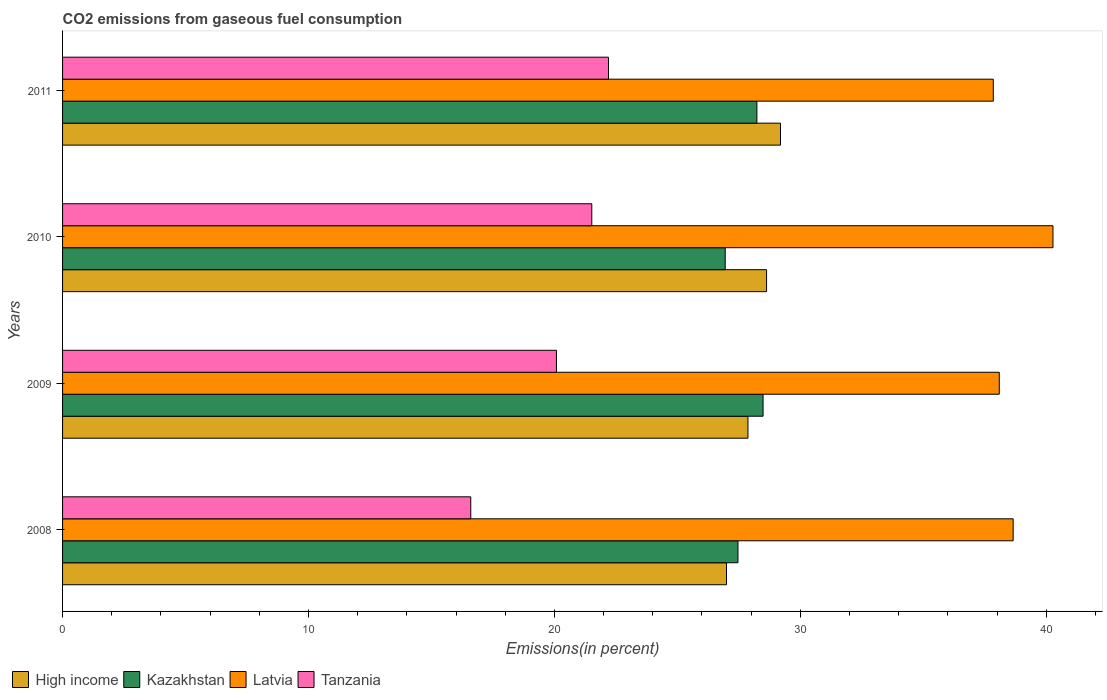Are the number of bars per tick equal to the number of legend labels?
Ensure brevity in your answer.  Yes. Are the number of bars on each tick of the Y-axis equal?
Give a very brief answer. Yes. How many bars are there on the 1st tick from the bottom?
Offer a terse response. 4. What is the label of the 2nd group of bars from the top?
Give a very brief answer. 2010. In how many cases, is the number of bars for a given year not equal to the number of legend labels?
Your answer should be very brief. 0. What is the total CO2 emitted in Kazakhstan in 2010?
Make the answer very short. 26.95. Across all years, what is the maximum total CO2 emitted in High income?
Ensure brevity in your answer.  29.19. Across all years, what is the minimum total CO2 emitted in Tanzania?
Ensure brevity in your answer.  16.6. In which year was the total CO2 emitted in Tanzania maximum?
Offer a terse response. 2011. What is the total total CO2 emitted in High income in the graph?
Ensure brevity in your answer.  112.69. What is the difference between the total CO2 emitted in Kazakhstan in 2008 and that in 2009?
Your answer should be compact. -1.02. What is the difference between the total CO2 emitted in Latvia in 2010 and the total CO2 emitted in Kazakhstan in 2011?
Ensure brevity in your answer.  12.04. What is the average total CO2 emitted in Kazakhstan per year?
Your answer should be very brief. 27.78. In the year 2010, what is the difference between the total CO2 emitted in High income and total CO2 emitted in Kazakhstan?
Provide a short and direct response. 1.68. What is the ratio of the total CO2 emitted in Kazakhstan in 2008 to that in 2009?
Your answer should be very brief. 0.96. Is the total CO2 emitted in High income in 2008 less than that in 2009?
Ensure brevity in your answer.  Yes. Is the difference between the total CO2 emitted in High income in 2010 and 2011 greater than the difference between the total CO2 emitted in Kazakhstan in 2010 and 2011?
Provide a short and direct response. Yes. What is the difference between the highest and the second highest total CO2 emitted in Latvia?
Provide a short and direct response. 1.62. What is the difference between the highest and the lowest total CO2 emitted in Latvia?
Offer a terse response. 2.43. In how many years, is the total CO2 emitted in Tanzania greater than the average total CO2 emitted in Tanzania taken over all years?
Provide a succinct answer. 2. Is it the case that in every year, the sum of the total CO2 emitted in Latvia and total CO2 emitted in High income is greater than the sum of total CO2 emitted in Kazakhstan and total CO2 emitted in Tanzania?
Offer a terse response. Yes. What does the 2nd bar from the bottom in 2011 represents?
Make the answer very short. Kazakhstan. Is it the case that in every year, the sum of the total CO2 emitted in Tanzania and total CO2 emitted in Kazakhstan is greater than the total CO2 emitted in High income?
Your answer should be very brief. Yes. How many years are there in the graph?
Make the answer very short. 4. What is the difference between two consecutive major ticks on the X-axis?
Give a very brief answer. 10. Does the graph contain any zero values?
Provide a succinct answer. No. Does the graph contain grids?
Ensure brevity in your answer.  No. Where does the legend appear in the graph?
Offer a terse response. Bottom left. How many legend labels are there?
Give a very brief answer. 4. What is the title of the graph?
Offer a very short reply. CO2 emissions from gaseous fuel consumption. Does "Botswana" appear as one of the legend labels in the graph?
Provide a succinct answer. No. What is the label or title of the X-axis?
Make the answer very short. Emissions(in percent). What is the label or title of the Y-axis?
Your answer should be compact. Years. What is the Emissions(in percent) in High income in 2008?
Ensure brevity in your answer.  27. What is the Emissions(in percent) of Kazakhstan in 2008?
Provide a short and direct response. 27.46. What is the Emissions(in percent) in Latvia in 2008?
Your response must be concise. 38.65. What is the Emissions(in percent) in Tanzania in 2008?
Offer a very short reply. 16.6. What is the Emissions(in percent) in High income in 2009?
Your response must be concise. 27.87. What is the Emissions(in percent) in Kazakhstan in 2009?
Your answer should be very brief. 28.48. What is the Emissions(in percent) of Latvia in 2009?
Your response must be concise. 38.09. What is the Emissions(in percent) of Tanzania in 2009?
Your response must be concise. 20.08. What is the Emissions(in percent) of High income in 2010?
Give a very brief answer. 28.63. What is the Emissions(in percent) of Kazakhstan in 2010?
Offer a terse response. 26.95. What is the Emissions(in percent) in Latvia in 2010?
Offer a very short reply. 40.27. What is the Emissions(in percent) of Tanzania in 2010?
Provide a succinct answer. 21.52. What is the Emissions(in percent) of High income in 2011?
Provide a succinct answer. 29.19. What is the Emissions(in percent) of Kazakhstan in 2011?
Provide a short and direct response. 28.23. What is the Emissions(in percent) of Latvia in 2011?
Give a very brief answer. 37.85. What is the Emissions(in percent) of Tanzania in 2011?
Keep it short and to the point. 22.2. Across all years, what is the maximum Emissions(in percent) of High income?
Provide a short and direct response. 29.19. Across all years, what is the maximum Emissions(in percent) in Kazakhstan?
Keep it short and to the point. 28.48. Across all years, what is the maximum Emissions(in percent) of Latvia?
Your answer should be compact. 40.27. Across all years, what is the maximum Emissions(in percent) of Tanzania?
Provide a succinct answer. 22.2. Across all years, what is the minimum Emissions(in percent) in High income?
Provide a short and direct response. 27. Across all years, what is the minimum Emissions(in percent) of Kazakhstan?
Your answer should be very brief. 26.95. Across all years, what is the minimum Emissions(in percent) in Latvia?
Give a very brief answer. 37.85. Across all years, what is the minimum Emissions(in percent) in Tanzania?
Offer a very short reply. 16.6. What is the total Emissions(in percent) of High income in the graph?
Give a very brief answer. 112.69. What is the total Emissions(in percent) in Kazakhstan in the graph?
Ensure brevity in your answer.  111.13. What is the total Emissions(in percent) of Latvia in the graph?
Provide a short and direct response. 154.87. What is the total Emissions(in percent) in Tanzania in the graph?
Your answer should be very brief. 80.4. What is the difference between the Emissions(in percent) of High income in 2008 and that in 2009?
Provide a short and direct response. -0.87. What is the difference between the Emissions(in percent) in Kazakhstan in 2008 and that in 2009?
Provide a short and direct response. -1.02. What is the difference between the Emissions(in percent) of Latvia in 2008 and that in 2009?
Offer a very short reply. 0.56. What is the difference between the Emissions(in percent) in Tanzania in 2008 and that in 2009?
Provide a short and direct response. -3.48. What is the difference between the Emissions(in percent) of High income in 2008 and that in 2010?
Offer a terse response. -1.63. What is the difference between the Emissions(in percent) in Kazakhstan in 2008 and that in 2010?
Keep it short and to the point. 0.52. What is the difference between the Emissions(in percent) in Latvia in 2008 and that in 2010?
Your answer should be compact. -1.62. What is the difference between the Emissions(in percent) in Tanzania in 2008 and that in 2010?
Provide a short and direct response. -4.92. What is the difference between the Emissions(in percent) of High income in 2008 and that in 2011?
Your response must be concise. -2.19. What is the difference between the Emissions(in percent) of Kazakhstan in 2008 and that in 2011?
Offer a very short reply. -0.77. What is the difference between the Emissions(in percent) in Latvia in 2008 and that in 2011?
Provide a succinct answer. 0.81. What is the difference between the Emissions(in percent) of Tanzania in 2008 and that in 2011?
Your response must be concise. -5.6. What is the difference between the Emissions(in percent) in High income in 2009 and that in 2010?
Offer a terse response. -0.76. What is the difference between the Emissions(in percent) of Kazakhstan in 2009 and that in 2010?
Give a very brief answer. 1.54. What is the difference between the Emissions(in percent) in Latvia in 2009 and that in 2010?
Offer a terse response. -2.18. What is the difference between the Emissions(in percent) of Tanzania in 2009 and that in 2010?
Offer a terse response. -1.44. What is the difference between the Emissions(in percent) of High income in 2009 and that in 2011?
Offer a terse response. -1.32. What is the difference between the Emissions(in percent) in Kazakhstan in 2009 and that in 2011?
Your response must be concise. 0.25. What is the difference between the Emissions(in percent) of Latvia in 2009 and that in 2011?
Offer a terse response. 0.24. What is the difference between the Emissions(in percent) of Tanzania in 2009 and that in 2011?
Provide a succinct answer. -2.12. What is the difference between the Emissions(in percent) of High income in 2010 and that in 2011?
Provide a succinct answer. -0.57. What is the difference between the Emissions(in percent) of Kazakhstan in 2010 and that in 2011?
Provide a short and direct response. -1.29. What is the difference between the Emissions(in percent) of Latvia in 2010 and that in 2011?
Give a very brief answer. 2.43. What is the difference between the Emissions(in percent) of Tanzania in 2010 and that in 2011?
Your answer should be compact. -0.68. What is the difference between the Emissions(in percent) of High income in 2008 and the Emissions(in percent) of Kazakhstan in 2009?
Your answer should be compact. -1.49. What is the difference between the Emissions(in percent) of High income in 2008 and the Emissions(in percent) of Latvia in 2009?
Ensure brevity in your answer.  -11.09. What is the difference between the Emissions(in percent) in High income in 2008 and the Emissions(in percent) in Tanzania in 2009?
Give a very brief answer. 6.92. What is the difference between the Emissions(in percent) of Kazakhstan in 2008 and the Emissions(in percent) of Latvia in 2009?
Your answer should be compact. -10.63. What is the difference between the Emissions(in percent) of Kazakhstan in 2008 and the Emissions(in percent) of Tanzania in 2009?
Keep it short and to the point. 7.38. What is the difference between the Emissions(in percent) in Latvia in 2008 and the Emissions(in percent) in Tanzania in 2009?
Offer a very short reply. 18.57. What is the difference between the Emissions(in percent) of High income in 2008 and the Emissions(in percent) of Kazakhstan in 2010?
Your answer should be compact. 0.05. What is the difference between the Emissions(in percent) of High income in 2008 and the Emissions(in percent) of Latvia in 2010?
Ensure brevity in your answer.  -13.28. What is the difference between the Emissions(in percent) of High income in 2008 and the Emissions(in percent) of Tanzania in 2010?
Ensure brevity in your answer.  5.48. What is the difference between the Emissions(in percent) of Kazakhstan in 2008 and the Emissions(in percent) of Latvia in 2010?
Make the answer very short. -12.81. What is the difference between the Emissions(in percent) of Kazakhstan in 2008 and the Emissions(in percent) of Tanzania in 2010?
Give a very brief answer. 5.94. What is the difference between the Emissions(in percent) in Latvia in 2008 and the Emissions(in percent) in Tanzania in 2010?
Make the answer very short. 17.13. What is the difference between the Emissions(in percent) in High income in 2008 and the Emissions(in percent) in Kazakhstan in 2011?
Provide a succinct answer. -1.24. What is the difference between the Emissions(in percent) of High income in 2008 and the Emissions(in percent) of Latvia in 2011?
Offer a terse response. -10.85. What is the difference between the Emissions(in percent) in High income in 2008 and the Emissions(in percent) in Tanzania in 2011?
Your answer should be very brief. 4.8. What is the difference between the Emissions(in percent) of Kazakhstan in 2008 and the Emissions(in percent) of Latvia in 2011?
Your answer should be compact. -10.38. What is the difference between the Emissions(in percent) of Kazakhstan in 2008 and the Emissions(in percent) of Tanzania in 2011?
Keep it short and to the point. 5.26. What is the difference between the Emissions(in percent) of Latvia in 2008 and the Emissions(in percent) of Tanzania in 2011?
Provide a succinct answer. 16.45. What is the difference between the Emissions(in percent) in High income in 2009 and the Emissions(in percent) in Kazakhstan in 2010?
Your answer should be compact. 0.92. What is the difference between the Emissions(in percent) in High income in 2009 and the Emissions(in percent) in Latvia in 2010?
Provide a succinct answer. -12.4. What is the difference between the Emissions(in percent) in High income in 2009 and the Emissions(in percent) in Tanzania in 2010?
Give a very brief answer. 6.35. What is the difference between the Emissions(in percent) in Kazakhstan in 2009 and the Emissions(in percent) in Latvia in 2010?
Your answer should be compact. -11.79. What is the difference between the Emissions(in percent) in Kazakhstan in 2009 and the Emissions(in percent) in Tanzania in 2010?
Make the answer very short. 6.96. What is the difference between the Emissions(in percent) of Latvia in 2009 and the Emissions(in percent) of Tanzania in 2010?
Offer a very short reply. 16.57. What is the difference between the Emissions(in percent) of High income in 2009 and the Emissions(in percent) of Kazakhstan in 2011?
Provide a short and direct response. -0.36. What is the difference between the Emissions(in percent) in High income in 2009 and the Emissions(in percent) in Latvia in 2011?
Make the answer very short. -9.98. What is the difference between the Emissions(in percent) of High income in 2009 and the Emissions(in percent) of Tanzania in 2011?
Your answer should be compact. 5.67. What is the difference between the Emissions(in percent) in Kazakhstan in 2009 and the Emissions(in percent) in Latvia in 2011?
Provide a succinct answer. -9.36. What is the difference between the Emissions(in percent) of Kazakhstan in 2009 and the Emissions(in percent) of Tanzania in 2011?
Offer a very short reply. 6.28. What is the difference between the Emissions(in percent) in Latvia in 2009 and the Emissions(in percent) in Tanzania in 2011?
Provide a succinct answer. 15.89. What is the difference between the Emissions(in percent) of High income in 2010 and the Emissions(in percent) of Kazakhstan in 2011?
Give a very brief answer. 0.39. What is the difference between the Emissions(in percent) in High income in 2010 and the Emissions(in percent) in Latvia in 2011?
Provide a short and direct response. -9.22. What is the difference between the Emissions(in percent) of High income in 2010 and the Emissions(in percent) of Tanzania in 2011?
Your answer should be compact. 6.43. What is the difference between the Emissions(in percent) of Kazakhstan in 2010 and the Emissions(in percent) of Latvia in 2011?
Offer a very short reply. -10.9. What is the difference between the Emissions(in percent) in Kazakhstan in 2010 and the Emissions(in percent) in Tanzania in 2011?
Keep it short and to the point. 4.75. What is the difference between the Emissions(in percent) in Latvia in 2010 and the Emissions(in percent) in Tanzania in 2011?
Your response must be concise. 18.07. What is the average Emissions(in percent) of High income per year?
Your response must be concise. 28.17. What is the average Emissions(in percent) of Kazakhstan per year?
Offer a terse response. 27.78. What is the average Emissions(in percent) in Latvia per year?
Provide a succinct answer. 38.72. What is the average Emissions(in percent) in Tanzania per year?
Offer a terse response. 20.1. In the year 2008, what is the difference between the Emissions(in percent) of High income and Emissions(in percent) of Kazakhstan?
Provide a short and direct response. -0.47. In the year 2008, what is the difference between the Emissions(in percent) in High income and Emissions(in percent) in Latvia?
Your response must be concise. -11.66. In the year 2008, what is the difference between the Emissions(in percent) in High income and Emissions(in percent) in Tanzania?
Make the answer very short. 10.4. In the year 2008, what is the difference between the Emissions(in percent) in Kazakhstan and Emissions(in percent) in Latvia?
Make the answer very short. -11.19. In the year 2008, what is the difference between the Emissions(in percent) in Kazakhstan and Emissions(in percent) in Tanzania?
Your response must be concise. 10.86. In the year 2008, what is the difference between the Emissions(in percent) of Latvia and Emissions(in percent) of Tanzania?
Keep it short and to the point. 22.06. In the year 2009, what is the difference between the Emissions(in percent) in High income and Emissions(in percent) in Kazakhstan?
Your response must be concise. -0.61. In the year 2009, what is the difference between the Emissions(in percent) of High income and Emissions(in percent) of Latvia?
Make the answer very short. -10.22. In the year 2009, what is the difference between the Emissions(in percent) in High income and Emissions(in percent) in Tanzania?
Offer a very short reply. 7.79. In the year 2009, what is the difference between the Emissions(in percent) in Kazakhstan and Emissions(in percent) in Latvia?
Your response must be concise. -9.61. In the year 2009, what is the difference between the Emissions(in percent) in Kazakhstan and Emissions(in percent) in Tanzania?
Ensure brevity in your answer.  8.4. In the year 2009, what is the difference between the Emissions(in percent) in Latvia and Emissions(in percent) in Tanzania?
Your response must be concise. 18.01. In the year 2010, what is the difference between the Emissions(in percent) in High income and Emissions(in percent) in Kazakhstan?
Your answer should be very brief. 1.68. In the year 2010, what is the difference between the Emissions(in percent) of High income and Emissions(in percent) of Latvia?
Offer a terse response. -11.65. In the year 2010, what is the difference between the Emissions(in percent) in High income and Emissions(in percent) in Tanzania?
Your answer should be compact. 7.11. In the year 2010, what is the difference between the Emissions(in percent) of Kazakhstan and Emissions(in percent) of Latvia?
Give a very brief answer. -13.33. In the year 2010, what is the difference between the Emissions(in percent) in Kazakhstan and Emissions(in percent) in Tanzania?
Provide a succinct answer. 5.43. In the year 2010, what is the difference between the Emissions(in percent) of Latvia and Emissions(in percent) of Tanzania?
Offer a terse response. 18.75. In the year 2011, what is the difference between the Emissions(in percent) in High income and Emissions(in percent) in Kazakhstan?
Your response must be concise. 0.96. In the year 2011, what is the difference between the Emissions(in percent) in High income and Emissions(in percent) in Latvia?
Provide a succinct answer. -8.65. In the year 2011, what is the difference between the Emissions(in percent) of High income and Emissions(in percent) of Tanzania?
Give a very brief answer. 6.99. In the year 2011, what is the difference between the Emissions(in percent) of Kazakhstan and Emissions(in percent) of Latvia?
Offer a very short reply. -9.61. In the year 2011, what is the difference between the Emissions(in percent) in Kazakhstan and Emissions(in percent) in Tanzania?
Ensure brevity in your answer.  6.03. In the year 2011, what is the difference between the Emissions(in percent) in Latvia and Emissions(in percent) in Tanzania?
Offer a terse response. 15.65. What is the ratio of the Emissions(in percent) of High income in 2008 to that in 2009?
Give a very brief answer. 0.97. What is the ratio of the Emissions(in percent) of Kazakhstan in 2008 to that in 2009?
Offer a terse response. 0.96. What is the ratio of the Emissions(in percent) of Latvia in 2008 to that in 2009?
Your response must be concise. 1.01. What is the ratio of the Emissions(in percent) in Tanzania in 2008 to that in 2009?
Ensure brevity in your answer.  0.83. What is the ratio of the Emissions(in percent) of High income in 2008 to that in 2010?
Offer a terse response. 0.94. What is the ratio of the Emissions(in percent) of Kazakhstan in 2008 to that in 2010?
Keep it short and to the point. 1.02. What is the ratio of the Emissions(in percent) of Latvia in 2008 to that in 2010?
Offer a terse response. 0.96. What is the ratio of the Emissions(in percent) in Tanzania in 2008 to that in 2010?
Your answer should be compact. 0.77. What is the ratio of the Emissions(in percent) in High income in 2008 to that in 2011?
Make the answer very short. 0.92. What is the ratio of the Emissions(in percent) in Kazakhstan in 2008 to that in 2011?
Ensure brevity in your answer.  0.97. What is the ratio of the Emissions(in percent) of Latvia in 2008 to that in 2011?
Keep it short and to the point. 1.02. What is the ratio of the Emissions(in percent) in Tanzania in 2008 to that in 2011?
Ensure brevity in your answer.  0.75. What is the ratio of the Emissions(in percent) of High income in 2009 to that in 2010?
Offer a very short reply. 0.97. What is the ratio of the Emissions(in percent) in Kazakhstan in 2009 to that in 2010?
Your response must be concise. 1.06. What is the ratio of the Emissions(in percent) in Latvia in 2009 to that in 2010?
Ensure brevity in your answer.  0.95. What is the ratio of the Emissions(in percent) of Tanzania in 2009 to that in 2010?
Ensure brevity in your answer.  0.93. What is the ratio of the Emissions(in percent) of High income in 2009 to that in 2011?
Keep it short and to the point. 0.95. What is the ratio of the Emissions(in percent) of Kazakhstan in 2009 to that in 2011?
Give a very brief answer. 1.01. What is the ratio of the Emissions(in percent) in Latvia in 2009 to that in 2011?
Your answer should be very brief. 1.01. What is the ratio of the Emissions(in percent) of Tanzania in 2009 to that in 2011?
Ensure brevity in your answer.  0.9. What is the ratio of the Emissions(in percent) of High income in 2010 to that in 2011?
Keep it short and to the point. 0.98. What is the ratio of the Emissions(in percent) of Kazakhstan in 2010 to that in 2011?
Ensure brevity in your answer.  0.95. What is the ratio of the Emissions(in percent) of Latvia in 2010 to that in 2011?
Make the answer very short. 1.06. What is the ratio of the Emissions(in percent) of Tanzania in 2010 to that in 2011?
Your answer should be compact. 0.97. What is the difference between the highest and the second highest Emissions(in percent) in High income?
Your answer should be compact. 0.57. What is the difference between the highest and the second highest Emissions(in percent) in Kazakhstan?
Your response must be concise. 0.25. What is the difference between the highest and the second highest Emissions(in percent) in Latvia?
Provide a succinct answer. 1.62. What is the difference between the highest and the second highest Emissions(in percent) in Tanzania?
Provide a succinct answer. 0.68. What is the difference between the highest and the lowest Emissions(in percent) of High income?
Provide a short and direct response. 2.19. What is the difference between the highest and the lowest Emissions(in percent) in Kazakhstan?
Make the answer very short. 1.54. What is the difference between the highest and the lowest Emissions(in percent) of Latvia?
Offer a very short reply. 2.43. What is the difference between the highest and the lowest Emissions(in percent) of Tanzania?
Provide a short and direct response. 5.6. 